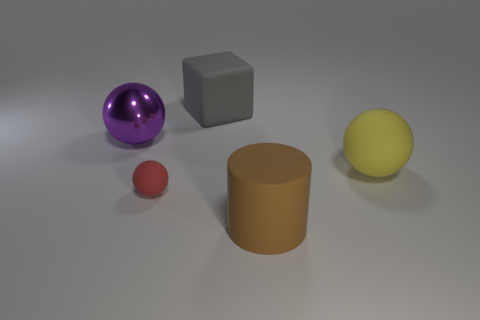Does the gray cube have the same size as the red rubber sphere that is to the left of the big yellow matte ball?
Provide a succinct answer. No. Are there any brown objects that have the same shape as the large yellow rubber object?
Your answer should be compact. No. What is the shape of the matte object that is both in front of the metal ball and on the left side of the large cylinder?
Give a very brief answer. Sphere. How many gray cubes have the same material as the tiny red ball?
Ensure brevity in your answer.  1. Are there fewer big yellow spheres that are to the right of the big cylinder than big purple things?
Give a very brief answer. No. There is a large brown rubber cylinder to the right of the large gray cube; are there any matte things that are in front of it?
Ensure brevity in your answer.  No. Is there anything else that is the same shape as the brown rubber object?
Offer a very short reply. No. Does the brown rubber cylinder have the same size as the purple metal thing?
Your answer should be compact. Yes. There is a big ball that is behind the sphere to the right of the big rubber object that is behind the big yellow ball; what is its material?
Ensure brevity in your answer.  Metal. Are there the same number of red objects that are in front of the brown matte thing and small red spheres?
Your answer should be very brief. No. 